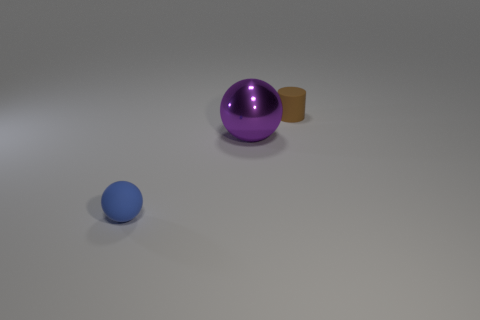Subtract 1 balls. How many balls are left? 1 Add 2 matte cylinders. How many objects exist? 5 Subtract all purple balls. How many balls are left? 1 Subtract all cylinders. How many objects are left? 2 Subtract all red spheres. Subtract all red cubes. How many spheres are left? 2 Subtract all cyan cubes. How many cyan cylinders are left? 0 Subtract all tiny brown objects. Subtract all small blue spheres. How many objects are left? 1 Add 1 small blue matte things. How many small blue matte things are left? 2 Add 1 large yellow matte cylinders. How many large yellow matte cylinders exist? 1 Subtract 1 purple balls. How many objects are left? 2 